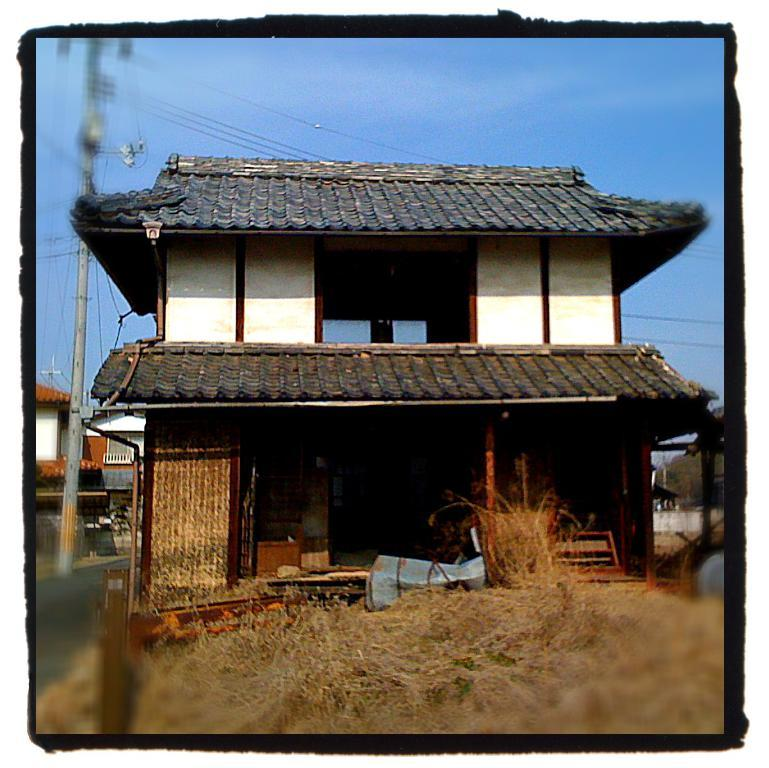What is the main subject of the image? The image contains a photograph. What can be seen in the photograph? There are electric poles, electric cables, buildings, a lawn with straw, a road, hills, and the sky visible in the photograph. Can you describe the describe the landscape in the photograph? The photograph features a landscape with hills, a road, and a lawn with straw. Are there any man-made structures in the photograph? Yes, there are electric poles, electric cables, and buildings in the photograph. What type of loaf is being used to hold the straw in the photograph? There is no loaf present in the photograph; it features a lawn with straw. Can you tell me how many drawers are visible in the photograph? There are no drawers present in the photograph; it features a landscape with hills, a road, and a lawn with straw. What color is the pail used to collect water from the electric poles in the photograph? There is no pail or water collection activity in the photograph; it features a landscape with hills, a road, and a lawn with straw. 